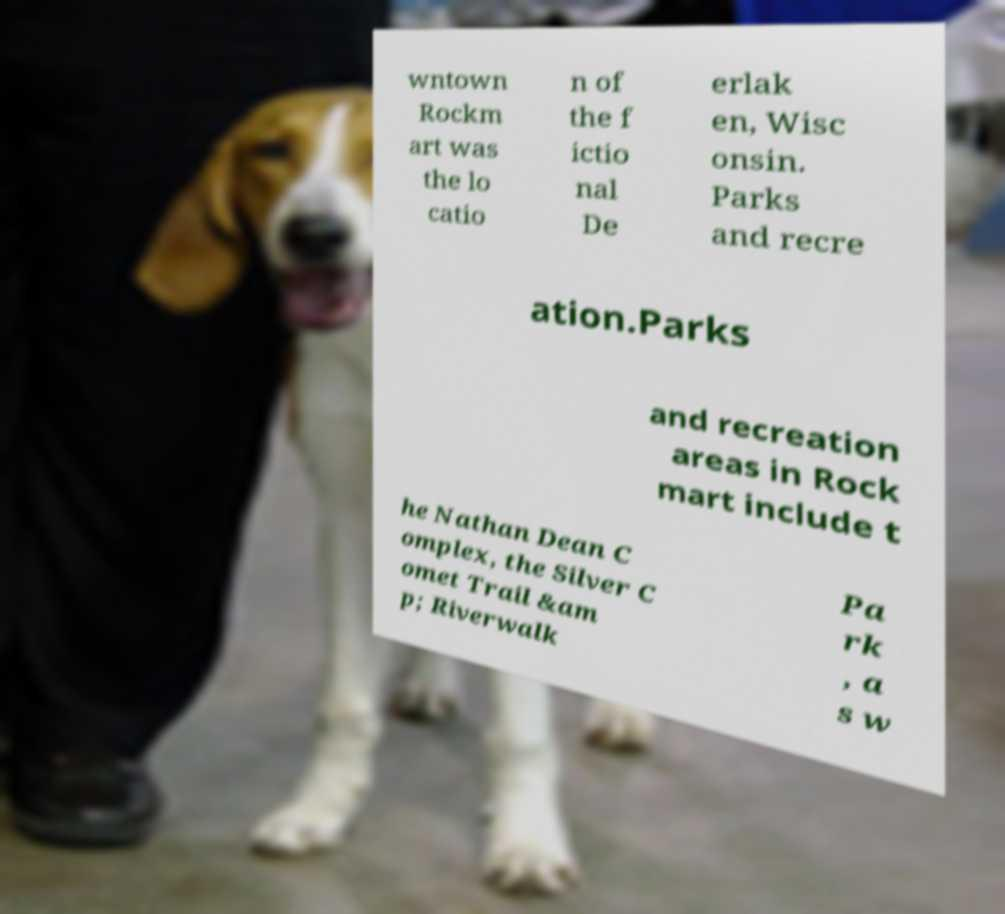Could you assist in decoding the text presented in this image and type it out clearly? wntown Rockm art was the lo catio n of the f ictio nal De erlak en, Wisc onsin. Parks and recre ation.Parks and recreation areas in Rock mart include t he Nathan Dean C omplex, the Silver C omet Trail &am p; Riverwalk Pa rk , a s w 